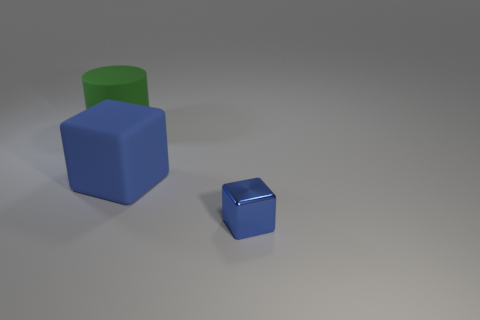There is a cube that is to the left of the metal thing; is its color the same as the block right of the blue matte object?
Offer a terse response. Yes. What color is the rubber thing that is in front of the big matte cylinder?
Give a very brief answer. Blue. How many other big matte objects have the same shape as the large blue matte thing?
Ensure brevity in your answer.  0. What material is the blue object that is the same size as the green object?
Make the answer very short. Rubber. Are there any tiny yellow things made of the same material as the big blue block?
Offer a terse response. No. The object that is both on the right side of the large matte cylinder and on the left side of the blue metal thing is what color?
Ensure brevity in your answer.  Blue. How many other things are there of the same color as the small thing?
Offer a terse response. 1. What is the big object in front of the large thing that is to the left of the blue block on the left side of the tiny shiny cube made of?
Offer a terse response. Rubber. What number of blocks are large blue objects or blue metal things?
Ensure brevity in your answer.  2. Are there any other things that have the same size as the shiny object?
Provide a succinct answer. No. 